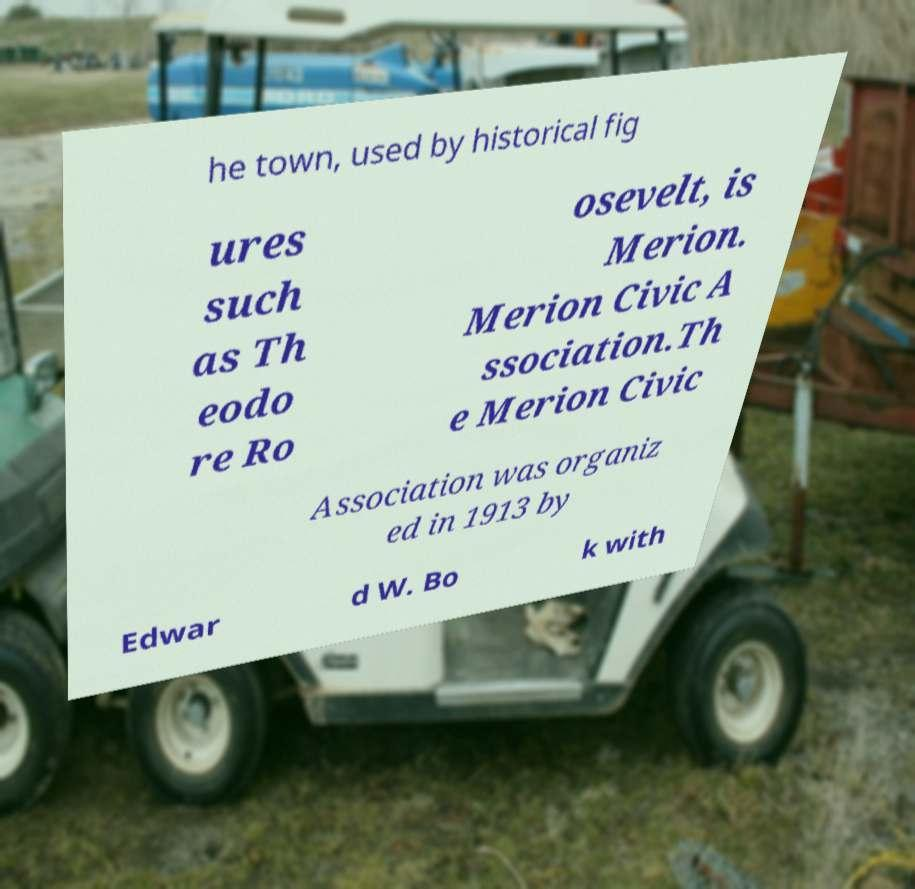There's text embedded in this image that I need extracted. Can you transcribe it verbatim? he town, used by historical fig ures such as Th eodo re Ro osevelt, is Merion. Merion Civic A ssociation.Th e Merion Civic Association was organiz ed in 1913 by Edwar d W. Bo k with 